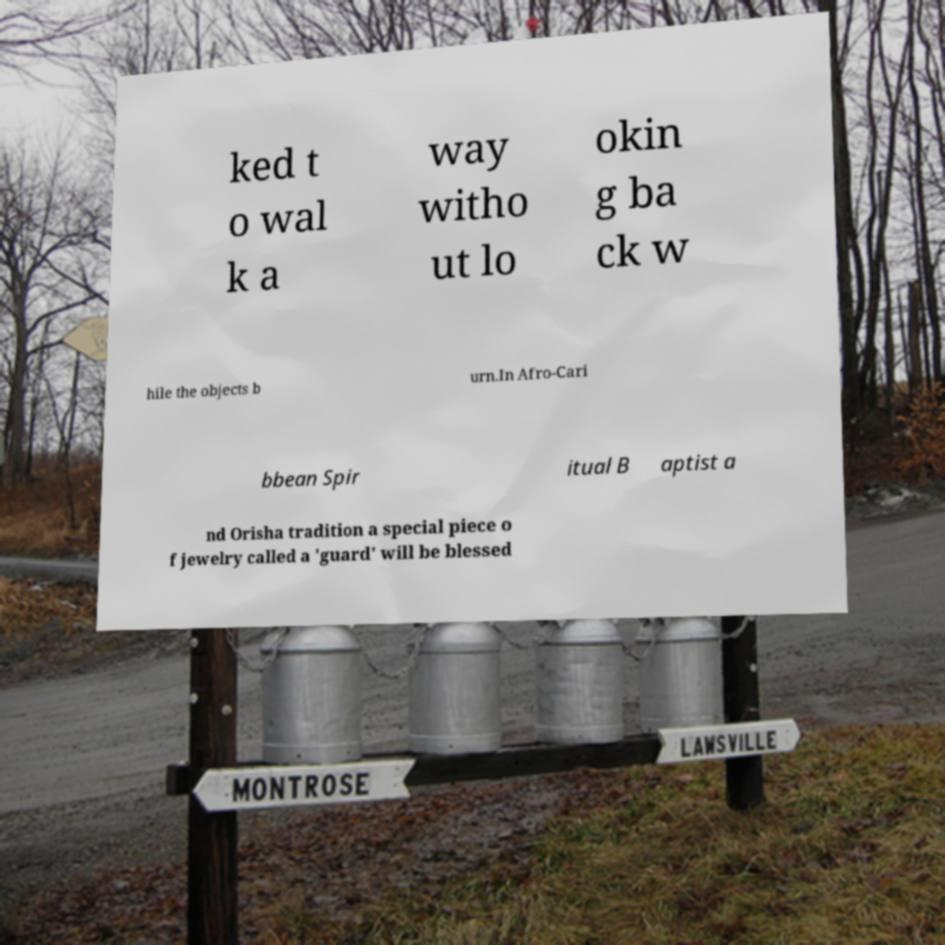For documentation purposes, I need the text within this image transcribed. Could you provide that? ked t o wal k a way witho ut lo okin g ba ck w hile the objects b urn.In Afro-Cari bbean Spir itual B aptist a nd Orisha tradition a special piece o f jewelry called a 'guard' will be blessed 